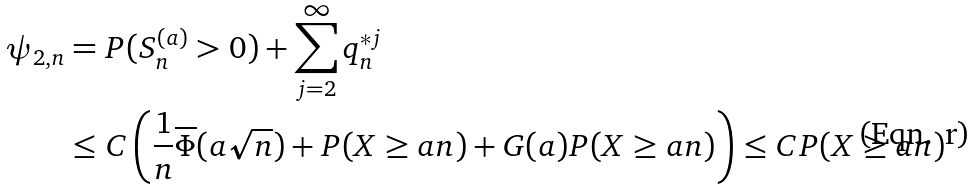Convert formula to latex. <formula><loc_0><loc_0><loc_500><loc_500>\psi _ { 2 , n } & = P ( S _ { n } ^ { ( a ) } > 0 ) + \sum _ { j = 2 } ^ { \infty } q ^ { * j } _ { n } \\ & \leq C \left ( \frac { 1 } { n } \overline { \Phi } ( a \sqrt { n } ) + P ( X \geq a n ) + G ( a ) P ( X \geq a n ) \right ) \leq C P ( X \geq a n )</formula> 